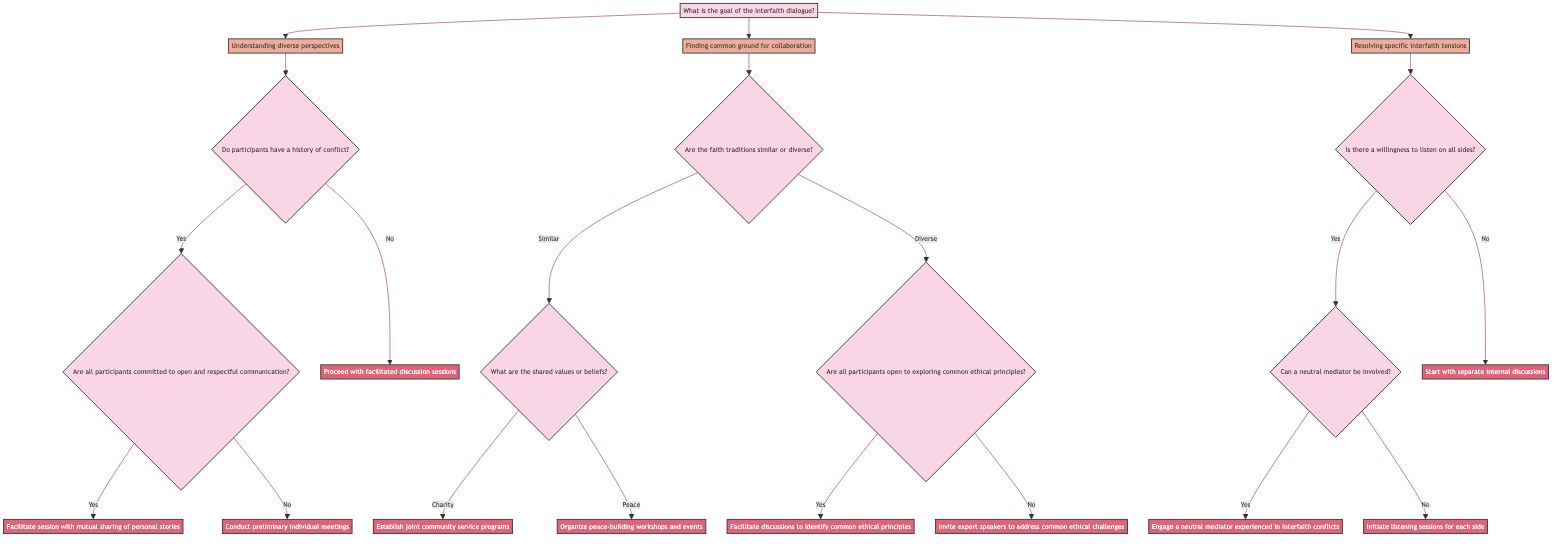What are the three main goals of the interfaith dialogue? The diagram lists three main goals at the root node: "Understanding diverse perspectives," "Finding common ground for collaboration," and "Resolving specific interfaith tensions."
Answer: Three main goals are: Understanding diverse perspectives, Finding common ground for collaboration, Resolving specific interfaith tensions How many follow-up questions are associated with the goal of understanding diverse perspectives? Following the goal "Understanding diverse perspectives," there is one follow-up question: "Do the participants have a history of conflict?" Thus, there is one associated follow-up question.
Answer: One follow-up question What action is recommended if participants do not have a history of conflict? According to the diagram, if the answer is "No" to the question regarding history of conflict, the recommended action is "Proceed with facilitated discussion sessions focusing on shared values and experiences."
Answer: Proceed with facilitated discussion sessions In the case of diverse faith traditions, what happens if the participants are not open to exploring common ethical principles? If the participants are not open to exploring common ethical principles, the follow-up indicates that the recommended action is to "Invite expert speakers to address common ethical challenges and solutions."
Answer: Invite expert speakers to address common ethical challenges How many total actions are there in this decision tree? There are a total of six actions in the diagram, as each branch presents different possible outcomes leading to distinct actions. Counting each node that represents an action gives the total.
Answer: Six actions What is the first decision point under the goal of finding common ground for collaboration? The first decision point under this goal is about the similarity or diversity of the faith traditions. It is framed as: "Are the faith traditions similar or diverse?"
Answer: Are the faith traditions similar or diverse? If there is a willingness to listen on all sides, what is the next question asked in the decision tree? When there is a willingness to listen, the next question is: "Can a neutral mediator be involved?" This guides the process based on the ability to include a mediator.
Answer: Can a neutral mediator be involved? What does the diagram suggest if there is no willingness to listen? The diagram indicates that if there is no willingness to listen, the action should be to "Start with separate internal discussions." This suggests addressing internal issues first before proceeding.
Answer: Start with separate internal discussions 